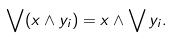Convert formula to latex. <formula><loc_0><loc_0><loc_500><loc_500>\bigvee ( x \wedge y _ { i } ) = x \wedge \bigvee y _ { i } .</formula> 